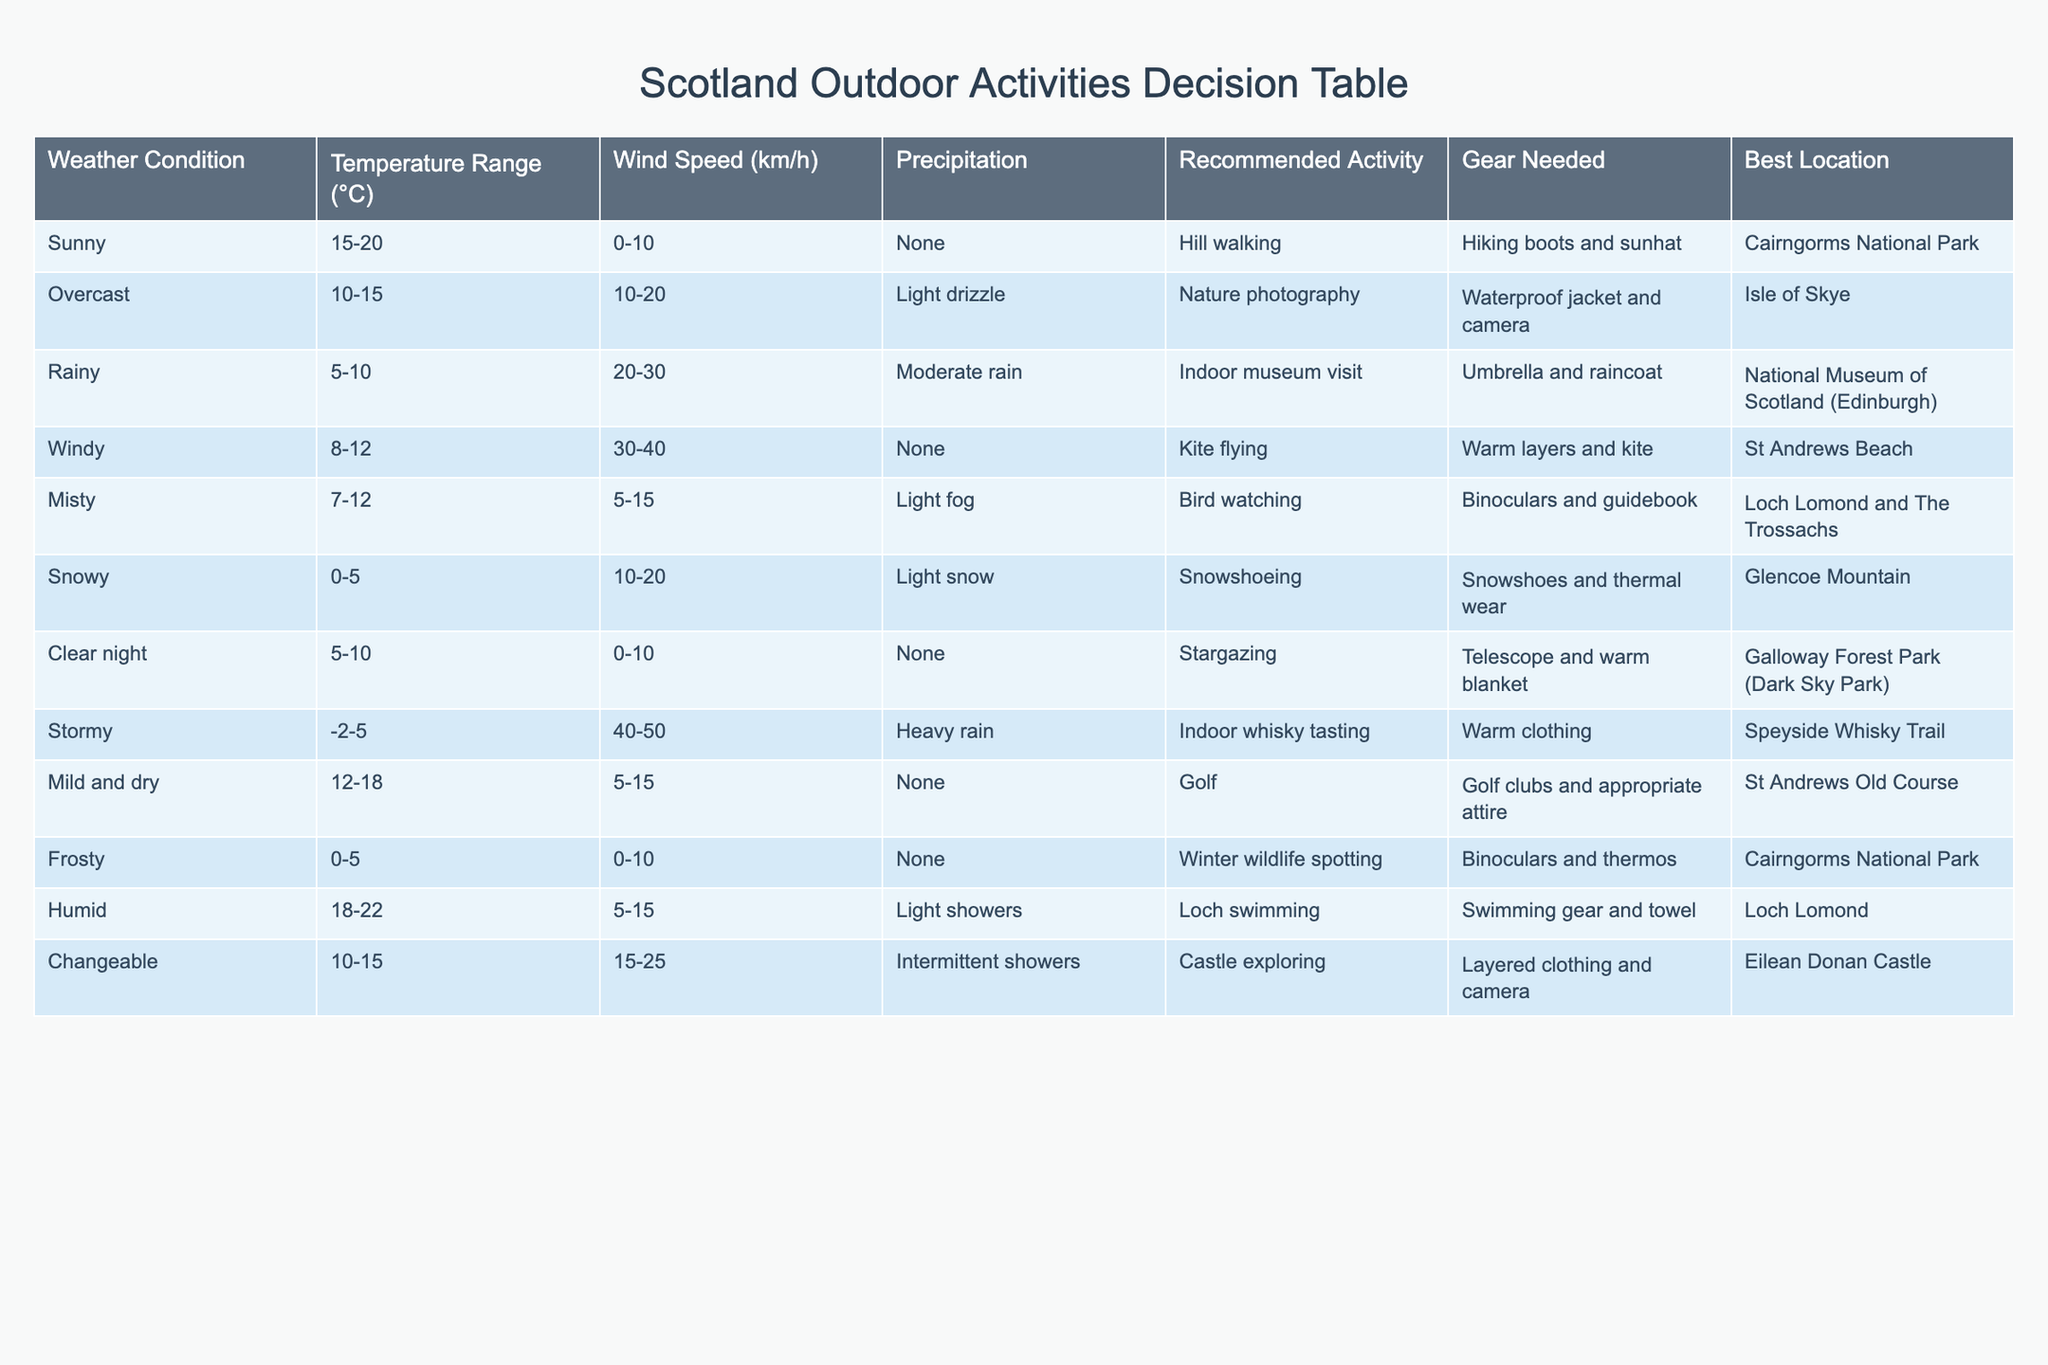What is the recommended activity for a sunny day? The table shows that under sunny weather conditions, the recommended activity is hill walking.
Answer: Hill walking Which location is best for nature photography during overcast weather? According to the table, when the weather is overcast, the Isle of Skye is the best location for nature photography.
Answer: Isle of Skye Are there any activities recommended when the weather is rainy? The table indicates that during rainy weather, the recommended activity is to visit an indoor museum.
Answer: Yes What gear is needed for kite flying in windy conditions? The table specifies that kite flying in windy conditions requires warm layers and a kite.
Answer: Warm layers and kite If the temperature is mild and dry at 12-18 °C, what activity is suggested? The table lists that a mild and dry temperature range suggests playing golf as the recommended activity.
Answer: Golf Which activity involves swimming gear and towel? The table points out that for humid weather conditions, the activity that requires swimming gear and a towel is loch swimming.
Answer: Loch swimming In what weather condition can you engage in winter wildlife spotting? The table states that winter wildlife spotting is recommended during frosty conditions, where the temperature is between 0-5 °C.
Answer: Frosty conditions What are the best locations for bird watching and hill walking? Bird watching is best at Loch Lomond and The Trossachs, while hill walking is recommended at Cairngorms National Park according to the table.
Answer: Loch Lomond and Cairngorms National Park Is indoor whisky tasting suggested for temperatures above 0 °C? The table shows that indoor whisky tasting is recommended in stormy weather with temperatures between -2 and 5 °C, which does not fit the criteria of being above 0 °C.
Answer: No 